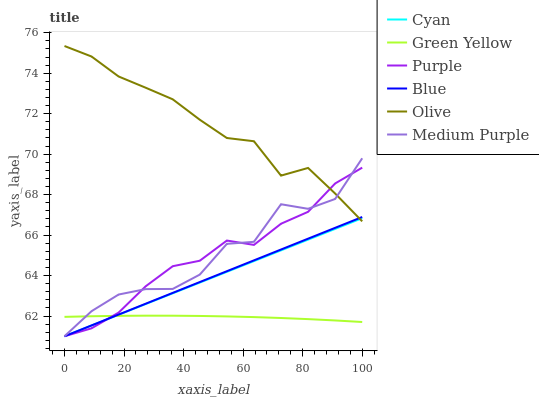Does Purple have the minimum area under the curve?
Answer yes or no. No. Does Purple have the maximum area under the curve?
Answer yes or no. No. Is Purple the smoothest?
Answer yes or no. No. Is Purple the roughest?
Answer yes or no. No. Does Olive have the lowest value?
Answer yes or no. No. Does Purple have the highest value?
Answer yes or no. No. Is Green Yellow less than Olive?
Answer yes or no. Yes. Is Olive greater than Green Yellow?
Answer yes or no. Yes. Does Green Yellow intersect Olive?
Answer yes or no. No. 